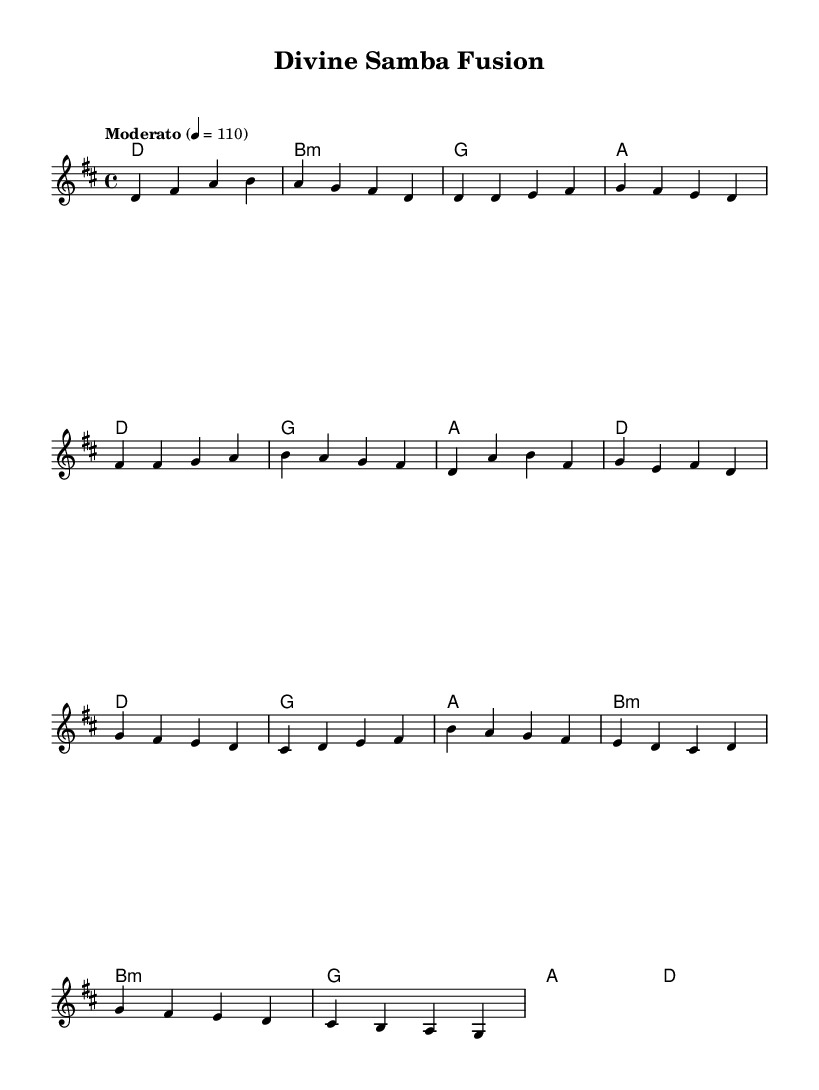What is the key signature of this music? The key signature has two sharps, indicating D major. This can be identified by looking at the beginning of the staff where the sharp symbols are placed, which correspond to F# and C#.
Answer: D major What is the time signature of the piece? The time signature is 4/4, as shown at the beginning of the score. This means there are four beats per measure and the quarter note receives one beat.
Answer: 4/4 What is the tempo marking of the piece? The tempo marking states "Moderato" with a metronome marking of 110. This indicates a moderate speed at which the piece should be played.
Answer: Moderato 110 What chord is played during the introduction? The first chord indicated in the harmonies section is D major, which is the root chord of the key signature. This can be determined by looking at the chord symbols listed in the harmonies.
Answer: D How many measures are in the verse section? The verse consists of three measures, as indicated by the series of notes and harmonies listed. Each measure can be counted based on the four beats per measure in the 4/4 time signature.
Answer: 3 What reference can be found in the bridge section? The bridge section contains a reference to "Ave Maria," indicated by the melodic line that corresponds to the hymn's recognizable notes. Recognizing this part requires familiarity with the hymn’s melody.
Answer: Ave Maria What type of musical fusion is this piece an example of? This piece is an example of Brazilian jazz fusion, which blends traditional Brazilian rhythms with elements of jazz. This can be inferred from the title "Divine Samba Fusion" and the musical style present in the melodies and harmonies.
Answer: Brazilian jazz fusion 